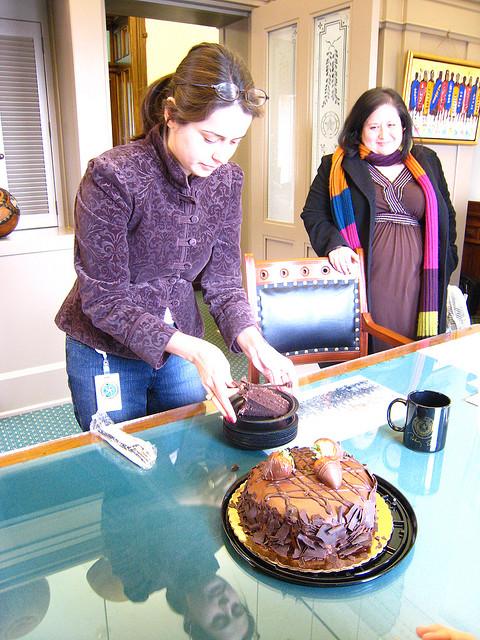Has the cake been cut?
Keep it brief. Yes. What fruit is on top of the cake?
Give a very brief answer. Strawberry. Is the woman looking at the camera or the cake?
Write a very short answer. Cake. 